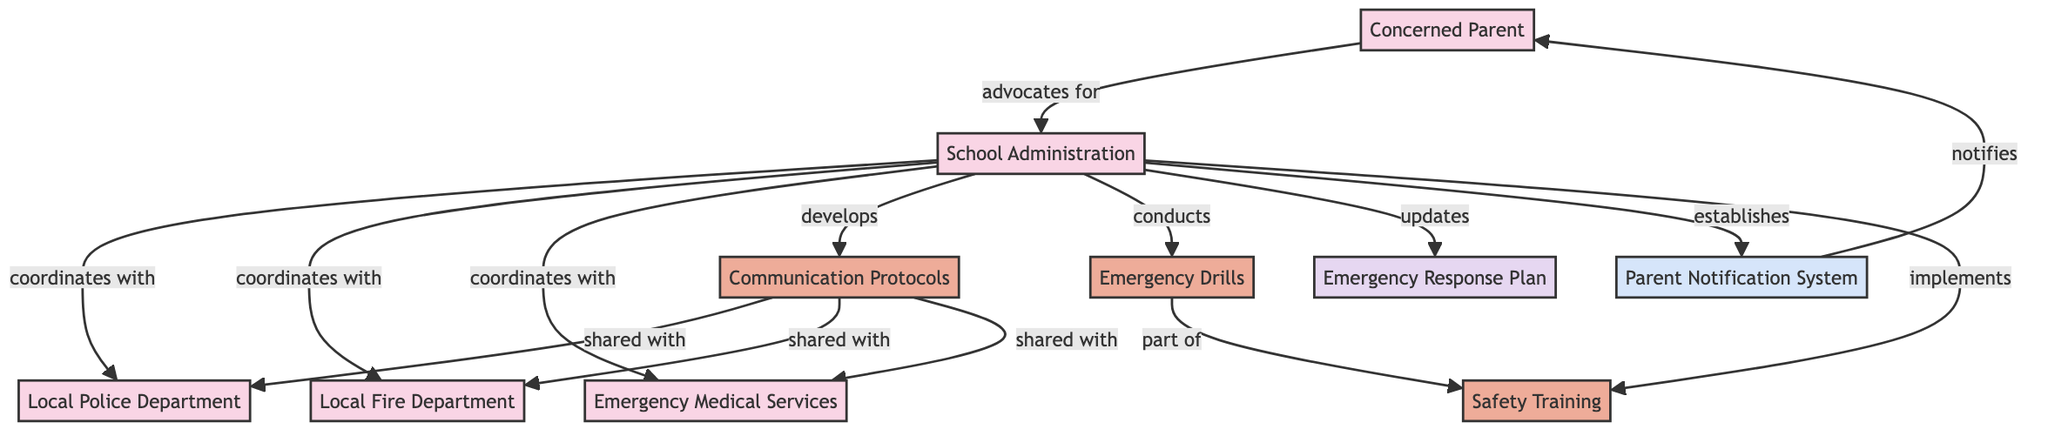What are the main actors listed in the diagram? The diagram includes five main actors: Concerned Parent, School Administration, Local Police Department, Local Fire Department, and Emergency Medical Services. These actors are distinctly identified as the entities participating in the coordination for safety strategies.
Answer: Concerned Parent, School Administration, Local Police Department, Local Fire Department, Emergency Medical Services How many processes are outlined in the diagram? There are four processes indicated in the diagram: Communication Protocols, Emergency Drills, Safety Training, and Emergency Response Plan. These processes detail the actions taken by the actors to enhance emergency preparedness in schools.
Answer: Four Which actor is responsible for establishing the Parent Notification System? The actor responsible for establishing the Parent Notification System is the School Administration. The connection is explicitly mentioned in the diagram, indicating the direct role of the School Administration in creating this system.
Answer: School Administration What type of document details the procedures to follow in emergencies? The document that outlines procedures to follow during emergencies is labeled as the Emergency Response Plan in the diagram. It specifies the course of action necessary when different emergency scenarios arise.
Answer: Emergency Response Plan Which actors share the Communication Protocols? The Communication Protocols are shared with the Local Police Department, Local Fire Department, and Emergency Medical Services. The connections indicate that these three response teams receive the protocols for coordinated communication.
Answer: Local Police Department, Local Fire Department, Emergency Medical Services How does the Parent Notification System interact with the Concerned Parent? The Parent Notification System notifies the Concerned Parent about emergencies. This connection reveals the mechanism through which parents are kept informed regarding urgent situations at schools.
Answer: Notifies What is part of the Safety Training process according to the diagram? Emergency Drills are part of the Safety Training process. This relationship shows that regular drills are integrated within training efforts to prepare students and staff for possible emergencies.
Answer: Emergency Drills Which two actors does the School Administration coordinate with? The School Administration coordinates with the Local Police Department and the Local Fire Department. This coordination is essential for ensuring effective emergency responses during incidents involving school safety.
Answer: Local Police Department, Local Fire Department What action do parents take in relation to the Emergency Response Plan? Parents do not directly engage with the Emergency Response Plan in the diagram; however, they are indirectly informed through processes like the Parent Notification System. The focus on parent involvement via notification suggests their role is primarily as recipients of information rather than active participants in the plan's creation.
Answer: Not applicable 